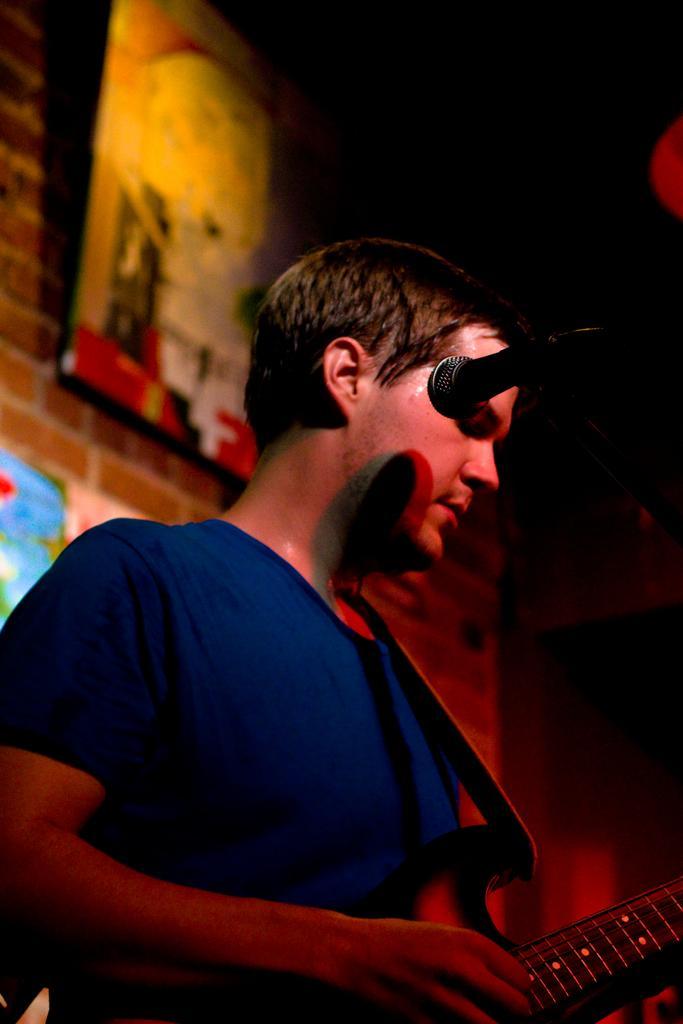Describe this image in one or two sentences. This image consists of a man who is holding a musical instrument. There is also a mic in front of him. He is wearing blue color t-shirt. Behind him there is a wall ,on that Wall on the top side of the image ,there are photo frames. 